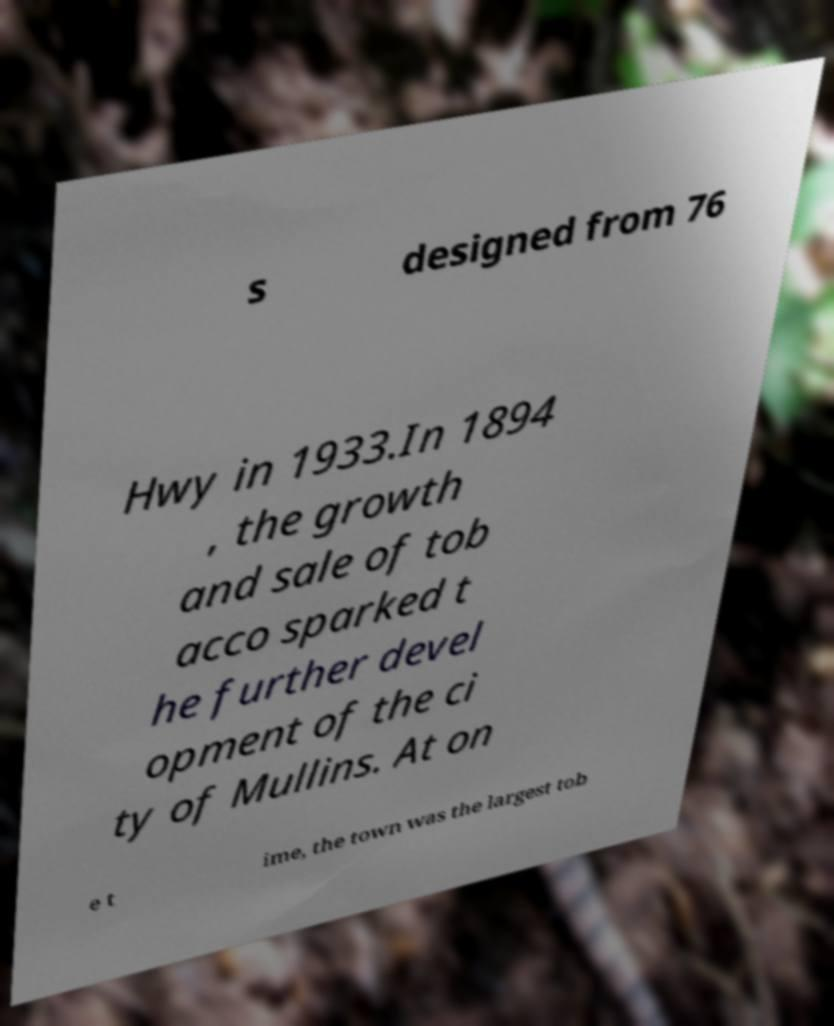Could you assist in decoding the text presented in this image and type it out clearly? s designed from 76 Hwy in 1933.In 1894 , the growth and sale of tob acco sparked t he further devel opment of the ci ty of Mullins. At on e t ime, the town was the largest tob 